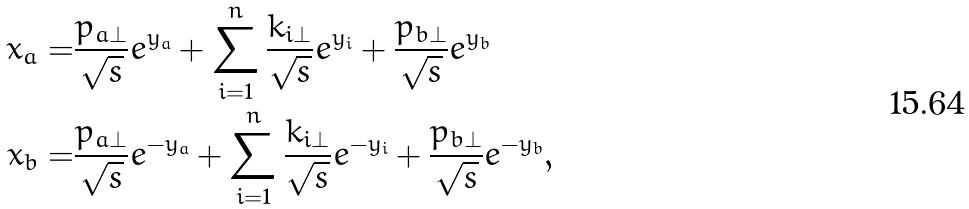Convert formula to latex. <formula><loc_0><loc_0><loc_500><loc_500>x _ { a } = & \frac { p _ { a \perp } } { \sqrt { s } } e ^ { y _ { a } } + \sum _ { i = 1 } ^ { n } \frac { k _ { i \perp } } { \sqrt { s } } e ^ { y _ { i } } + \frac { p _ { b \perp } } { \sqrt { s } } e ^ { y _ { b } } \\ x _ { b } = & \frac { p _ { a \perp } } { \sqrt { s } } e ^ { - y _ { a } } + \sum _ { i = 1 } ^ { n } \frac { k _ { i \perp } } { \sqrt { s } } e ^ { - y _ { i } } + \frac { p _ { b \perp } } { \sqrt { s } } e ^ { - y _ { b } } ,</formula> 